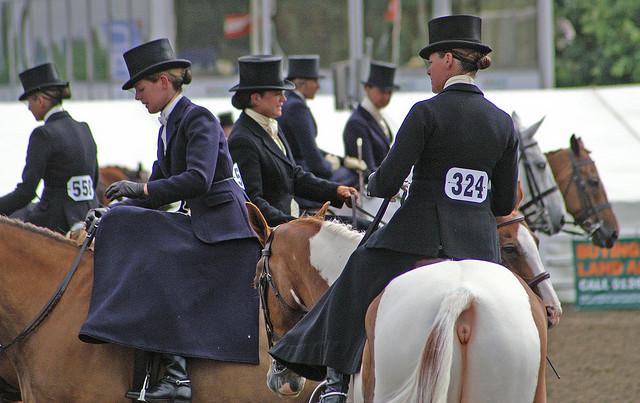What kind of hats are they wearing?
Be succinct. Top hats. What color is the women's hat?
Keep it brief. Black. What sport is this?
Give a very brief answer. Polo. Is there anyone wearing green?
Keep it brief. No. In what direction is the closest woman rider facing?
Quick response, please. Left. What are they riding?
Concise answer only. Horses. 